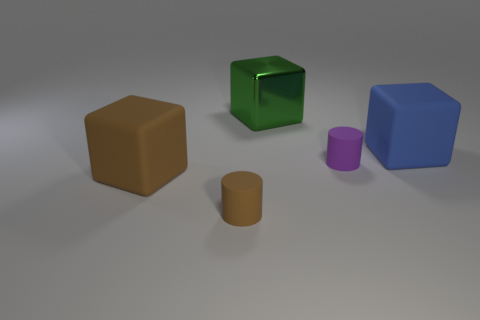There is another thing that is the same size as the purple rubber thing; what is it made of? The object in the image that appears to be the same size as the purple cylindrical object seems to be made of a similar matte material, likely a plastic or a non-reflective painted surface, based on how the light interacts with its surface. 